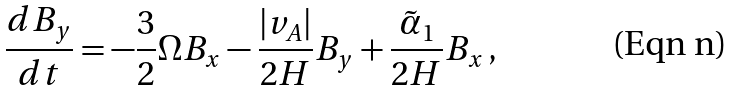Convert formula to latex. <formula><loc_0><loc_0><loc_500><loc_500>\frac { d B _ { y } } { d t } = - \frac { 3 } { 2 } \Omega B _ { x } - \frac { | v _ { A } | } { 2 H } B _ { y } + \frac { \tilde { \alpha } _ { 1 } } { 2 H } B _ { x } \, ,</formula> 